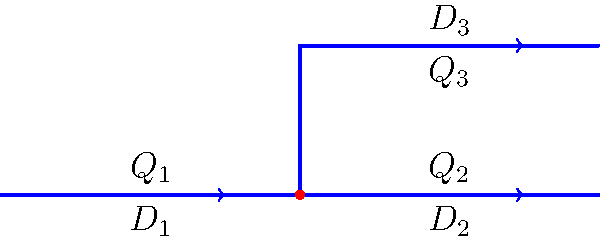In the pipe network shown, water flows from left to right. The diameters of the pipes are $D_1 = 100$ mm, $D_2 = 80$ mm, and $D_3 = 60$ mm. If the flow rate in pipe 1 is $Q_1 = 0.1$ m³/s, what is the average velocity $v_3$ in pipe 3, assuming steady, incompressible flow? To solve this problem, we'll use the continuity equation and the given information. Let's proceed step by step:

1) First, we need to understand that for incompressible flow, the mass flow rate is conserved. This means that the total flow rate entering the junction must equal the total flow rate leaving the junction.

2) At the junction: $Q_1 = Q_2 + Q_3$

3) We know $Q_1 = 0.1$ m³/s, but we don't know the individual flow rates in pipes 2 and 3. However, we can use the relationship between flow rate and velocity:

   $Q = Av = \frac{\pi D^2}{4}v$

4) We need to find $v_3$, so let's express $Q_3$ in terms of $v_3$:

   $Q_3 = \frac{\pi D_3^2}{4}v_3 = \frac{\pi (0.06\text{ m})^2}{4}v_3 = 0.002827v_3$

5) Now, let's express $Q_2$ in terms of $Q_1$ and $Q_3$:

   $Q_2 = Q_1 - Q_3 = 0.1 - 0.002827v_3$

6) We can also express $Q_2$ in terms of $v_2$:

   $Q_2 = \frac{\pi D_2^2}{4}v_2 = \frac{\pi (0.08\text{ m})^2}{4}v_2 = 0.005027v_2$

7) Equating these two expressions for $Q_2$:

   $0.1 - 0.002827v_3 = 0.005027v_2$

8) We now have one equation with two unknowns. We need another equation. We can use the fact that the pressure drop in parallel pipes (2 and 3) must be equal. In laminar flow, pressure drop is proportional to velocity and inversely proportional to the square of diameter. So:

   $\frac{v_2}{D_2^2} = \frac{v_3}{D_3^2}$

9) Substituting the known diameters:

   $\frac{v_2}{0.08^2} = \frac{v_3}{0.06^2}$

   $v_2 = \frac{16}{9}v_3$

10) Substituting this into our equation from step 7:

    $0.1 - 0.002827v_3 = 0.005027(\frac{16}{9}v_3)$

11) Solving for $v_3$:

    $0.1 = 0.002827v_3 + 0.008937v_3 = 0.011764v_3$

    $v_3 = \frac{0.1}{0.011764} = 8.5$ m/s

Therefore, the average velocity in pipe 3 is approximately 8.5 m/s.
Answer: 8.5 m/s 